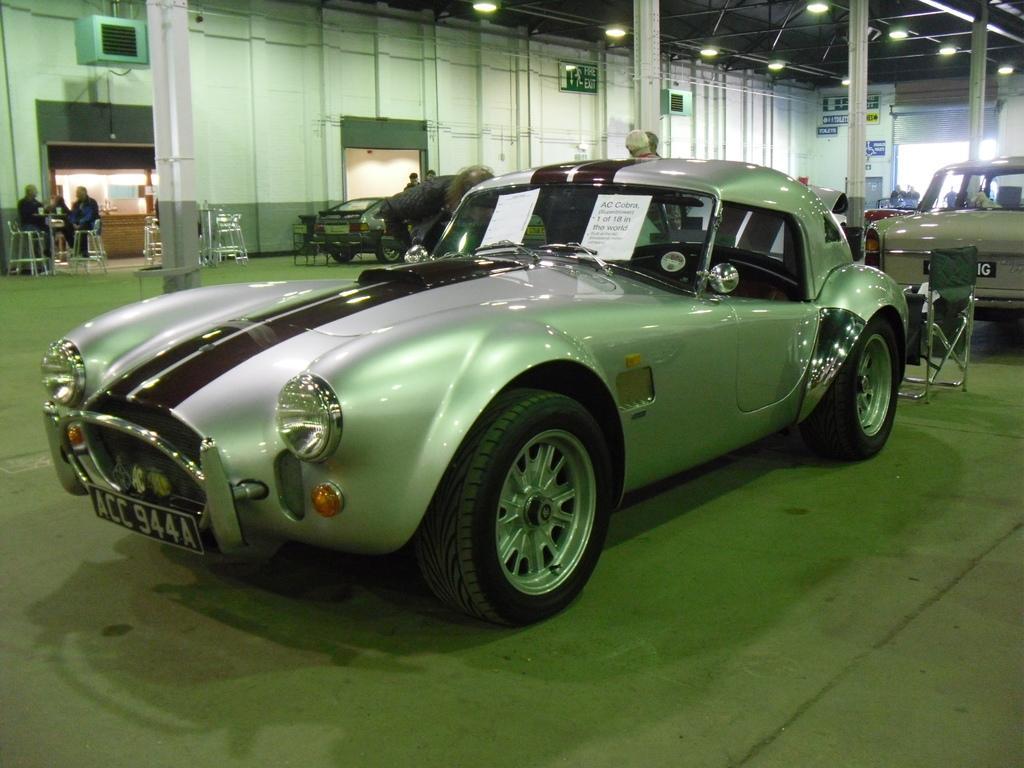Could you give a brief overview of what you see in this image? In this image I can see the ground and a car which is ash and brown in color. I can see two pages attached to the windshield of the car. In the background I can see few persons standing, few chairs, few persons sitting on chairs, the wall, the ceiling, few lights to the ceiling, few pillars and few other vehicles. 